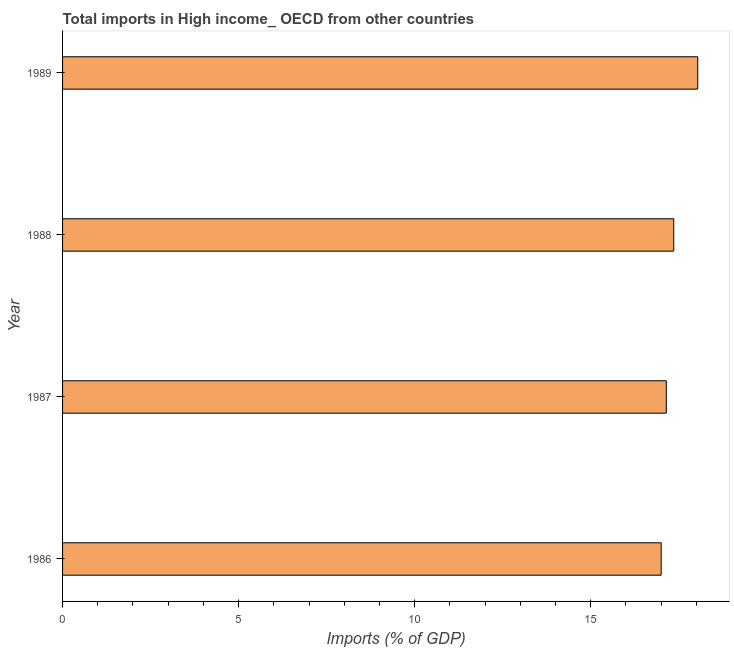Does the graph contain any zero values?
Provide a short and direct response. No. Does the graph contain grids?
Make the answer very short. No. What is the title of the graph?
Give a very brief answer. Total imports in High income_ OECD from other countries. What is the label or title of the X-axis?
Your response must be concise. Imports (% of GDP). What is the label or title of the Y-axis?
Provide a short and direct response. Year. What is the total imports in 1988?
Provide a succinct answer. 17.36. Across all years, what is the maximum total imports?
Ensure brevity in your answer.  18.04. Across all years, what is the minimum total imports?
Give a very brief answer. 17. What is the sum of the total imports?
Your answer should be compact. 69.54. What is the difference between the total imports in 1987 and 1988?
Make the answer very short. -0.21. What is the average total imports per year?
Your response must be concise. 17.39. What is the median total imports?
Make the answer very short. 17.25. In how many years, is the total imports greater than 6 %?
Give a very brief answer. 4. Do a majority of the years between 1987 and 1989 (inclusive) have total imports greater than 14 %?
Your answer should be compact. Yes. What is the ratio of the total imports in 1987 to that in 1989?
Make the answer very short. 0.95. Is the difference between the total imports in 1986 and 1987 greater than the difference between any two years?
Your answer should be compact. No. What is the difference between the highest and the second highest total imports?
Your answer should be compact. 0.68. What is the difference between the highest and the lowest total imports?
Provide a short and direct response. 1.04. Are all the bars in the graph horizontal?
Provide a short and direct response. Yes. What is the Imports (% of GDP) in 1986?
Your answer should be compact. 17. What is the Imports (% of GDP) of 1987?
Make the answer very short. 17.15. What is the Imports (% of GDP) of 1988?
Offer a terse response. 17.36. What is the Imports (% of GDP) in 1989?
Your answer should be compact. 18.04. What is the difference between the Imports (% of GDP) in 1986 and 1987?
Provide a short and direct response. -0.15. What is the difference between the Imports (% of GDP) in 1986 and 1988?
Make the answer very short. -0.36. What is the difference between the Imports (% of GDP) in 1986 and 1989?
Offer a very short reply. -1.04. What is the difference between the Imports (% of GDP) in 1987 and 1988?
Ensure brevity in your answer.  -0.21. What is the difference between the Imports (% of GDP) in 1987 and 1989?
Your response must be concise. -0.89. What is the difference between the Imports (% of GDP) in 1988 and 1989?
Provide a short and direct response. -0.68. What is the ratio of the Imports (% of GDP) in 1986 to that in 1988?
Provide a short and direct response. 0.98. What is the ratio of the Imports (% of GDP) in 1986 to that in 1989?
Give a very brief answer. 0.94. What is the ratio of the Imports (% of GDP) in 1987 to that in 1988?
Provide a succinct answer. 0.99. What is the ratio of the Imports (% of GDP) in 1987 to that in 1989?
Offer a terse response. 0.95. What is the ratio of the Imports (% of GDP) in 1988 to that in 1989?
Ensure brevity in your answer.  0.96. 